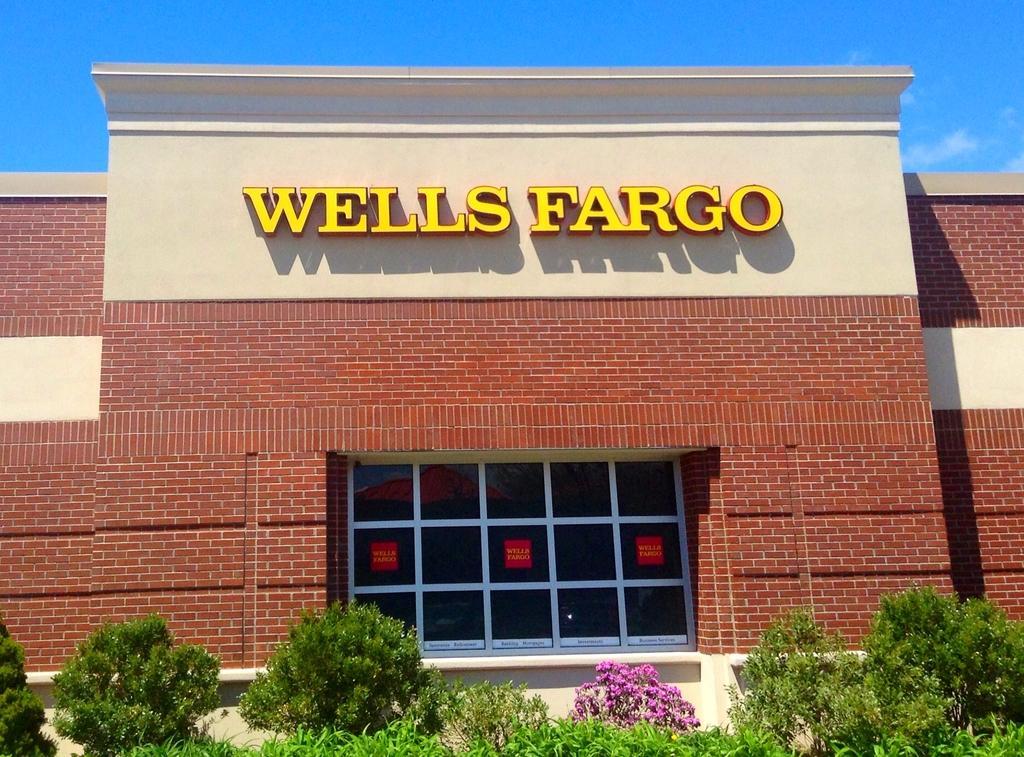In one or two sentences, can you explain what this image depicts? In this picture we can see the building, in which we can see a glass window, in front of the building we can see some plants. 